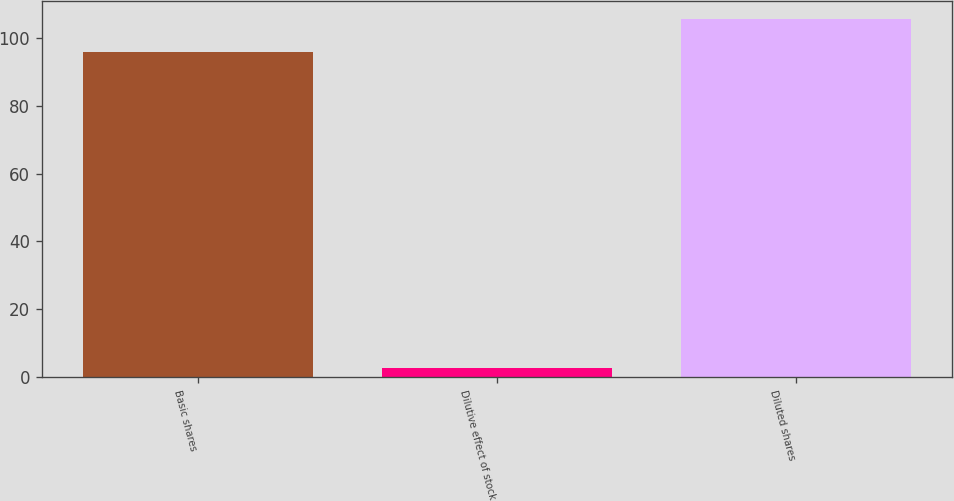<chart> <loc_0><loc_0><loc_500><loc_500><bar_chart><fcel>Basic shares<fcel>Dilutive effect of stock<fcel>Diluted shares<nl><fcel>96<fcel>2.7<fcel>105.6<nl></chart> 